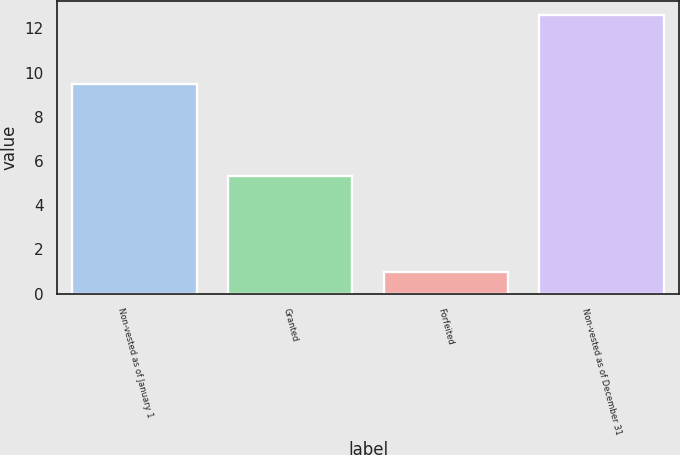Convert chart to OTSL. <chart><loc_0><loc_0><loc_500><loc_500><bar_chart><fcel>Non-vested as of January 1<fcel>Granted<fcel>Forfeited<fcel>Non-vested as of December 31<nl><fcel>9.5<fcel>5.3<fcel>1<fcel>12.6<nl></chart> 